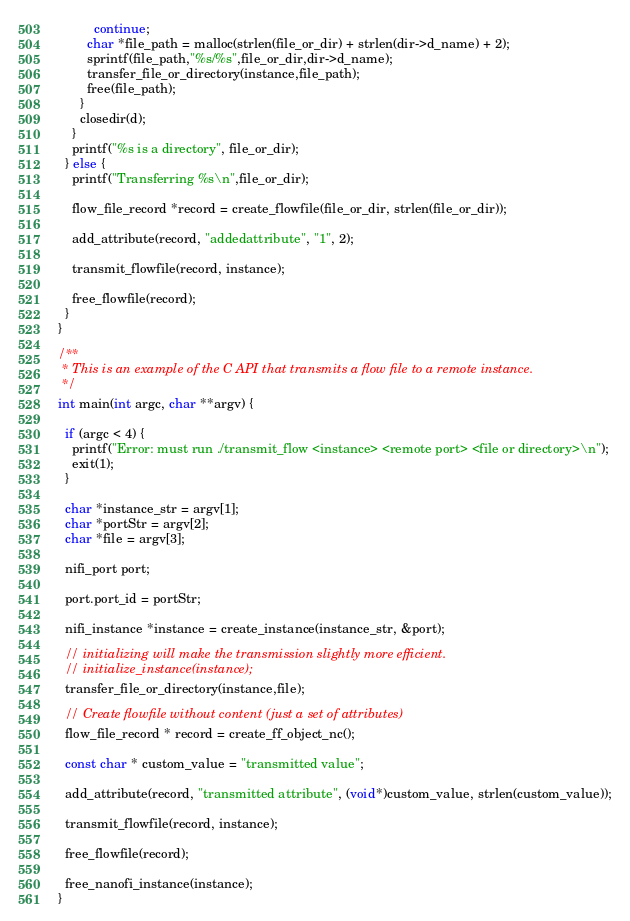<code> <loc_0><loc_0><loc_500><loc_500><_C_>          continue;
        char *file_path = malloc(strlen(file_or_dir) + strlen(dir->d_name) + 2);
        sprintf(file_path,"%s/%s",file_or_dir,dir->d_name);
        transfer_file_or_directory(instance,file_path);
        free(file_path);
      }
      closedir(d);
    }
    printf("%s is a directory", file_or_dir);
  } else {
    printf("Transferring %s\n",file_or_dir);

    flow_file_record *record = create_flowfile(file_or_dir, strlen(file_or_dir));

    add_attribute(record, "addedattribute", "1", 2);

    transmit_flowfile(record, instance);

    free_flowfile(record);
  }
}

/**
 * This is an example of the C API that transmits a flow file to a remote instance.
 */
int main(int argc, char **argv) {

  if (argc < 4) {
    printf("Error: must run ./transmit_flow <instance> <remote port> <file or directory>\n");
    exit(1);
  }

  char *instance_str = argv[1];
  char *portStr = argv[2];
  char *file = argv[3];

  nifi_port port;

  port.port_id = portStr;

  nifi_instance *instance = create_instance(instance_str, &port);

  // initializing will make the transmission slightly more efficient.
  // initialize_instance(instance);
  transfer_file_or_directory(instance,file);

  // Create flowfile without content (just a set of attributes)
  flow_file_record * record = create_ff_object_nc();

  const char * custom_value = "transmitted value";

  add_attribute(record, "transmitted attribute", (void*)custom_value, strlen(custom_value));

  transmit_flowfile(record, instance);

  free_flowfile(record);

  free_nanofi_instance(instance);
}


</code> 